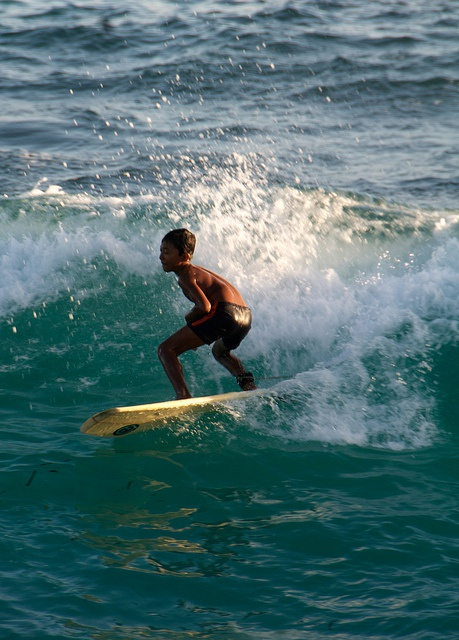Describe the objects in this image and their specific colors. I can see people in gray, black, maroon, tan, and brown tones and surfboard in gray, olive, tan, black, and khaki tones in this image. 